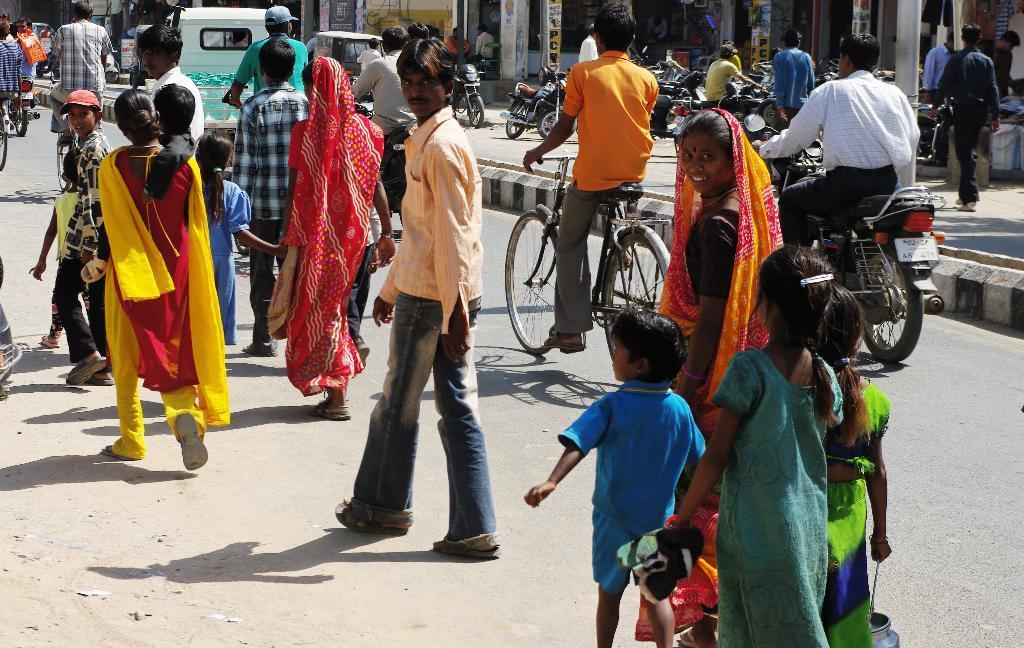How would you summarize this image in a sentence or two? This is the image where few people are walking on the road. Here we can see a bike, cycle and a trolley auto moving on the road. In the background of the image we can see many bikes parked over there. 